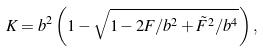<formula> <loc_0><loc_0><loc_500><loc_500>K = b ^ { 2 } \left ( 1 - \sqrt { 1 - { 2 F } / { b ^ { 2 } } + { { \tilde { F } } ^ { 2 } } / { b ^ { 4 } } } \right ) ,</formula> 